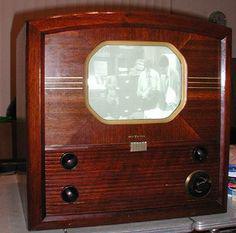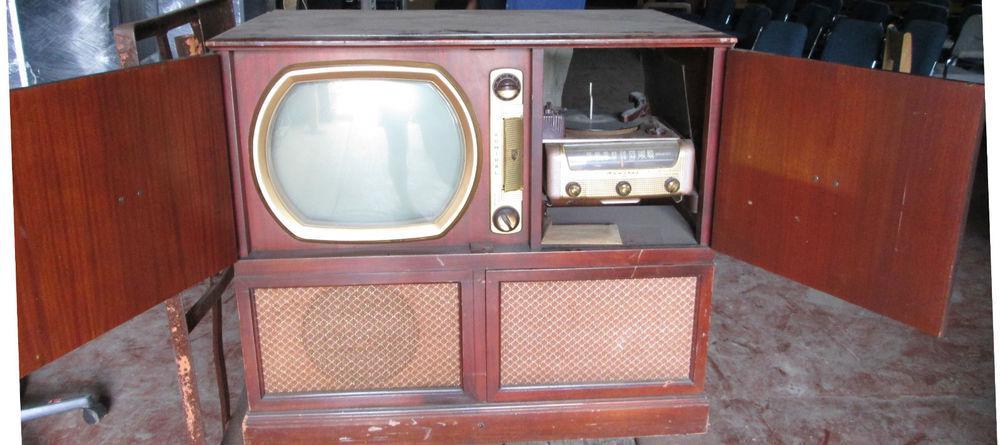The first image is the image on the left, the second image is the image on the right. Given the left and right images, does the statement "In at least one image there is a small rectangle tv sitting on a white table." hold true? Answer yes or no. No. The first image is the image on the left, the second image is the image on the right. Analyze the images presented: Is the assertion "A television is turned on." valid? Answer yes or no. Yes. 